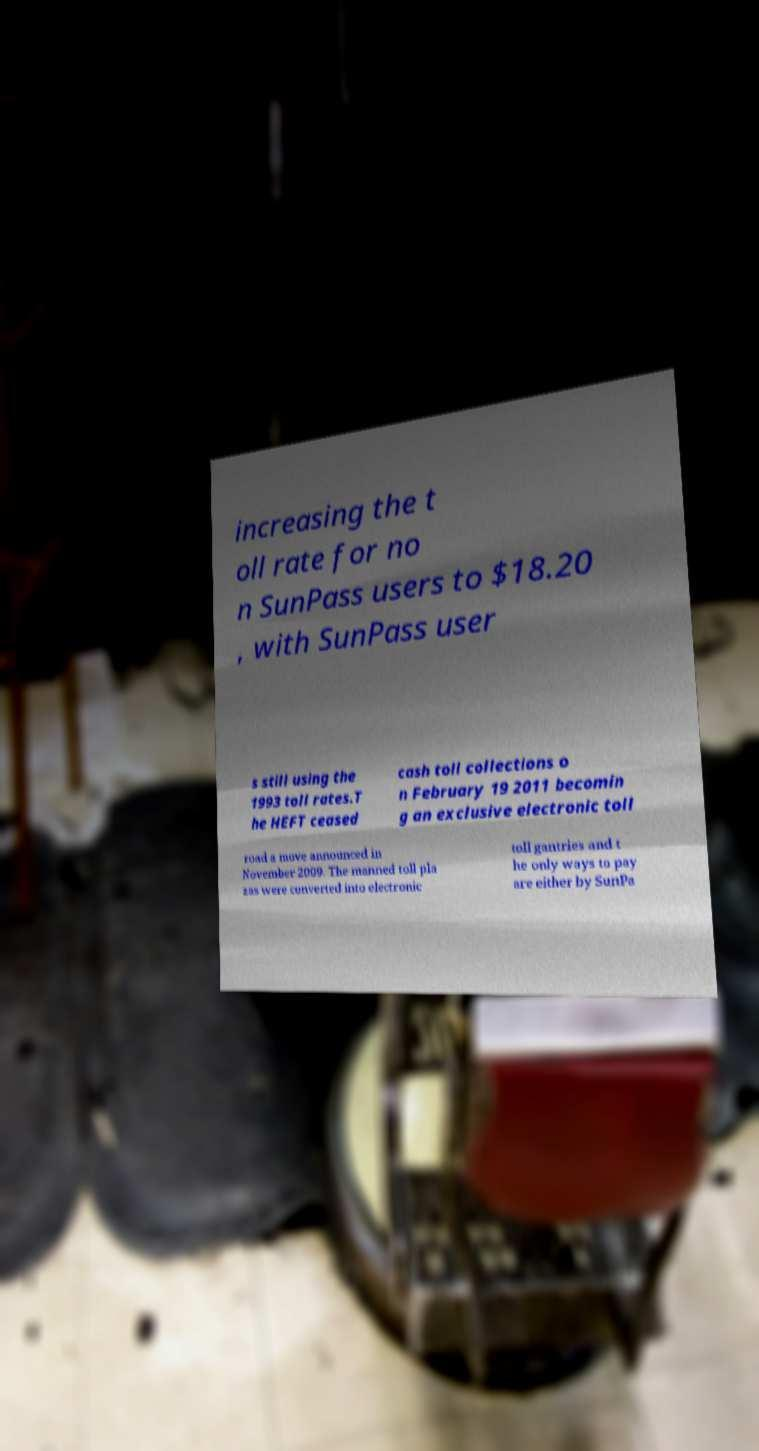Could you assist in decoding the text presented in this image and type it out clearly? increasing the t oll rate for no n SunPass users to $18.20 , with SunPass user s still using the 1993 toll rates.T he HEFT ceased cash toll collections o n February 19 2011 becomin g an exclusive electronic toll road a move announced in November 2009. The manned toll pla zas were converted into electronic toll gantries and t he only ways to pay are either by SunPa 